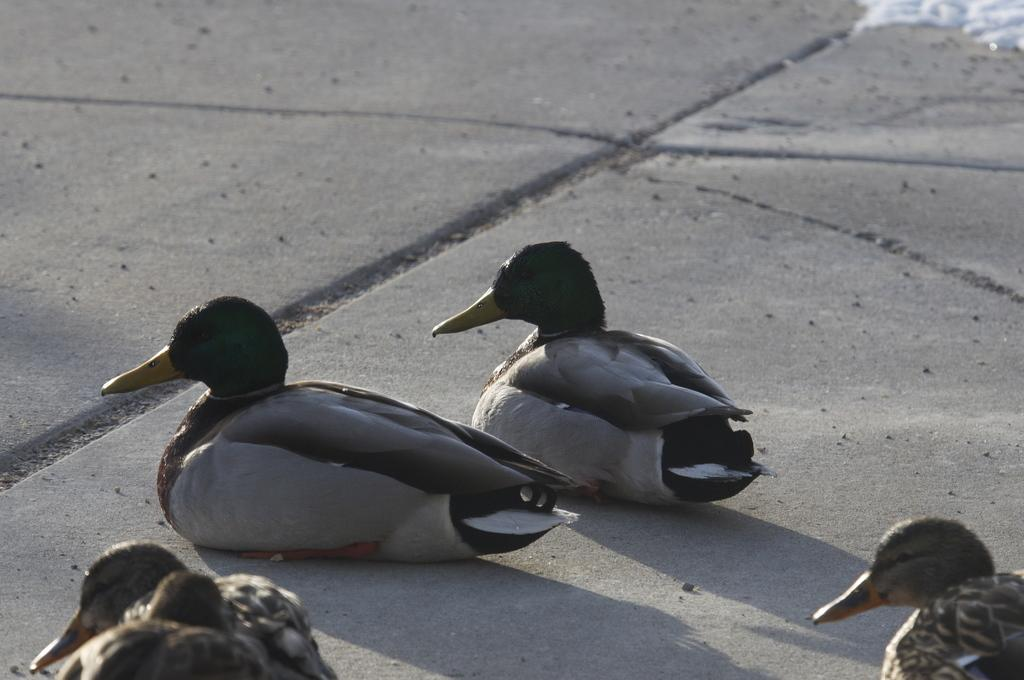What type of animals can be seen on the ground in the image? There are birds on the ground in the image. Can you describe the white colored object in the image? There is a white colored object in the top right corner of the image. How many frogs can be seen in the image? There are no frogs present in the image; it features birds on the ground and a white colored object in the top right corner. What type of gardening tool is being used by the birds in the image? There is no gardening tool, such as a rake, present in the image. 